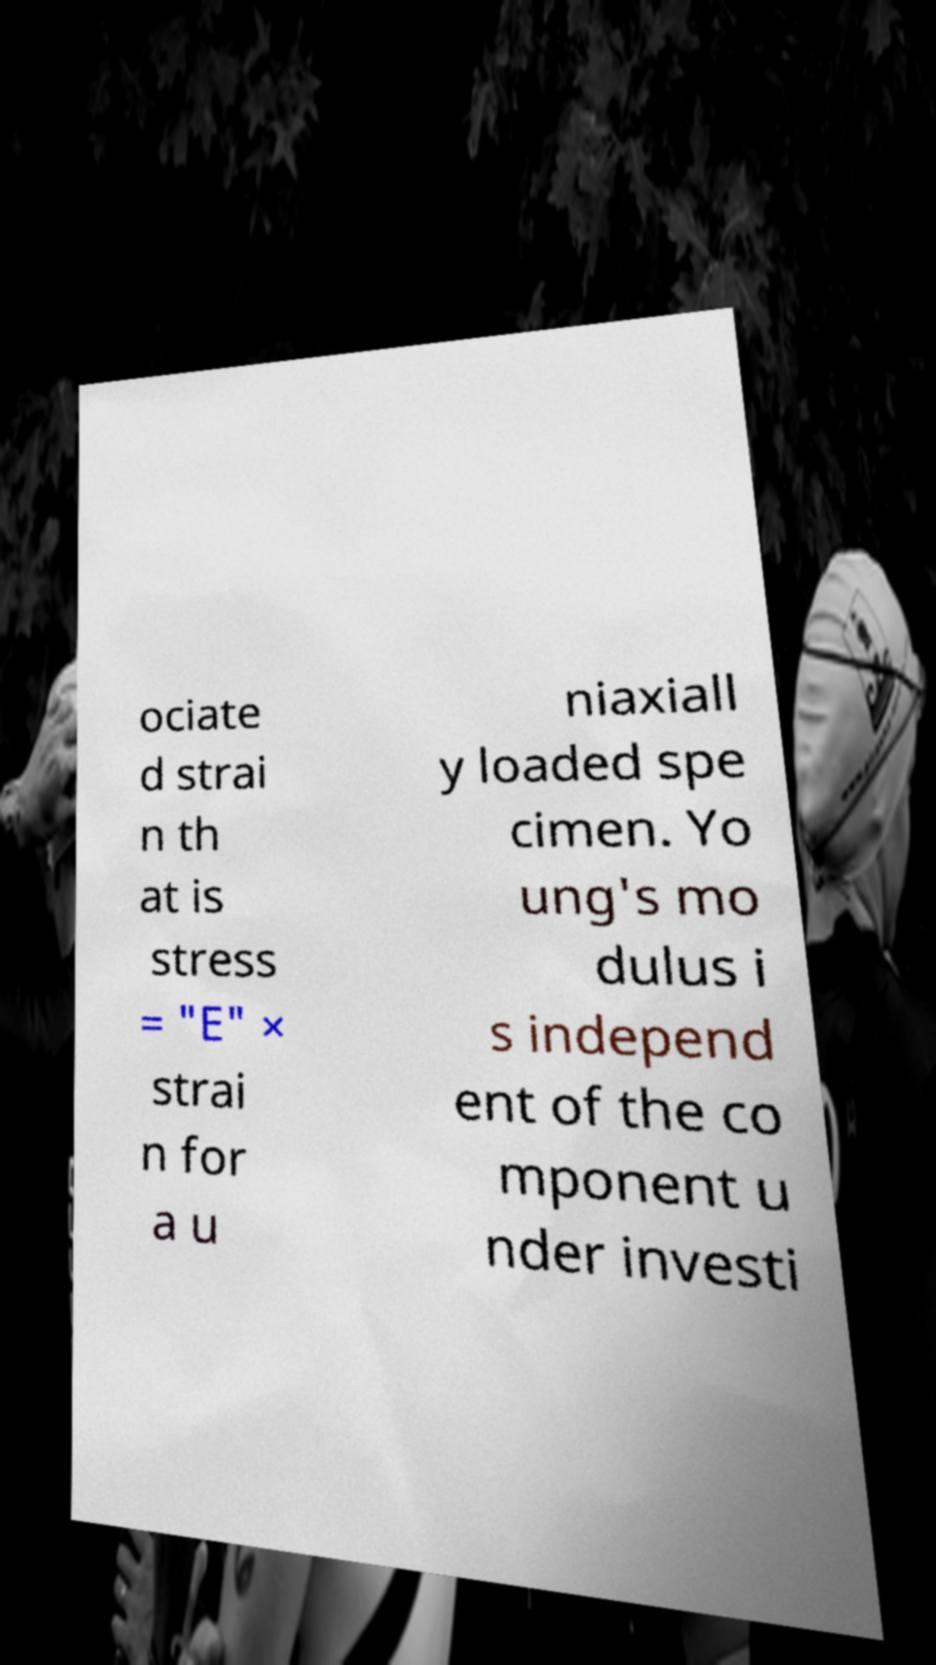Could you assist in decoding the text presented in this image and type it out clearly? ociate d strai n th at is stress = "E" × strai n for a u niaxiall y loaded spe cimen. Yo ung's mo dulus i s independ ent of the co mponent u nder investi 